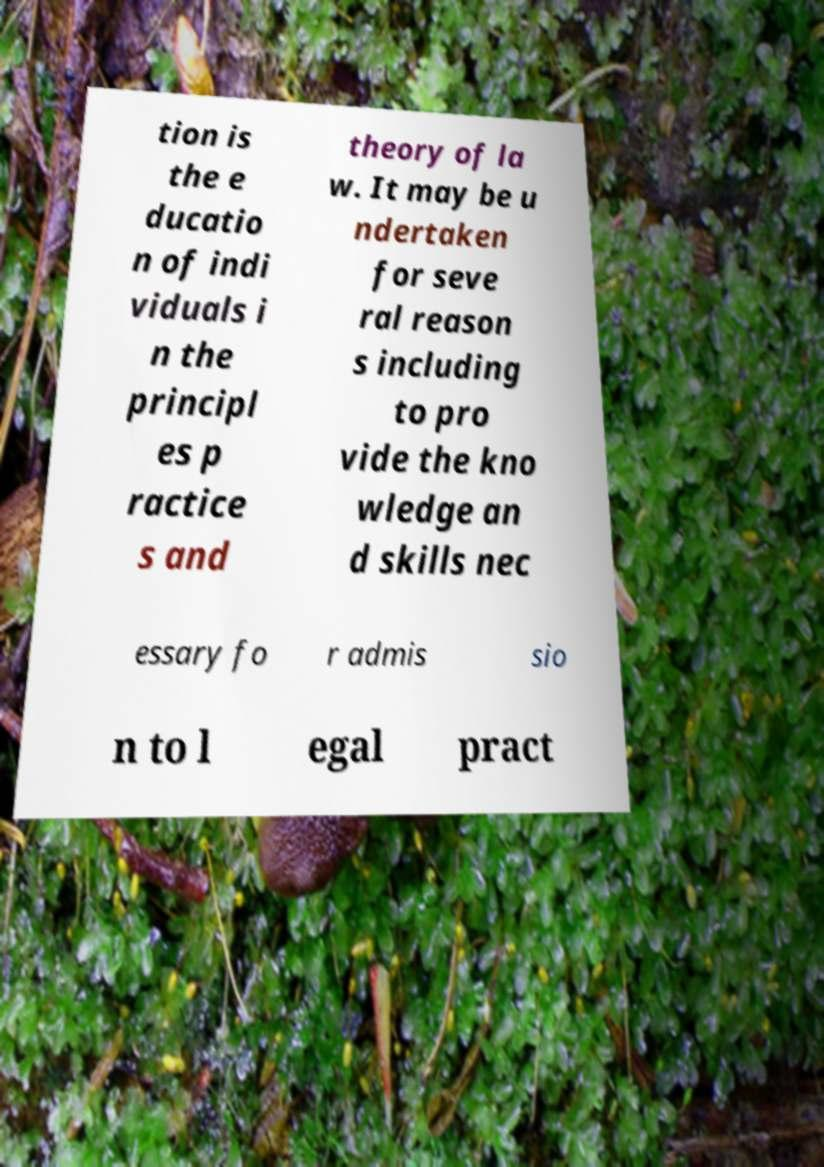Could you extract and type out the text from this image? tion is the e ducatio n of indi viduals i n the principl es p ractice s and theory of la w. It may be u ndertaken for seve ral reason s including to pro vide the kno wledge an d skills nec essary fo r admis sio n to l egal pract 